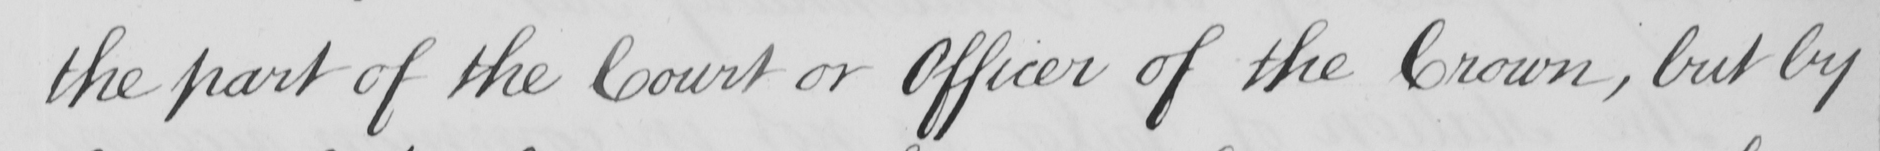What text is written in this handwritten line? the part of the Court or Officer of the Crown , but by 